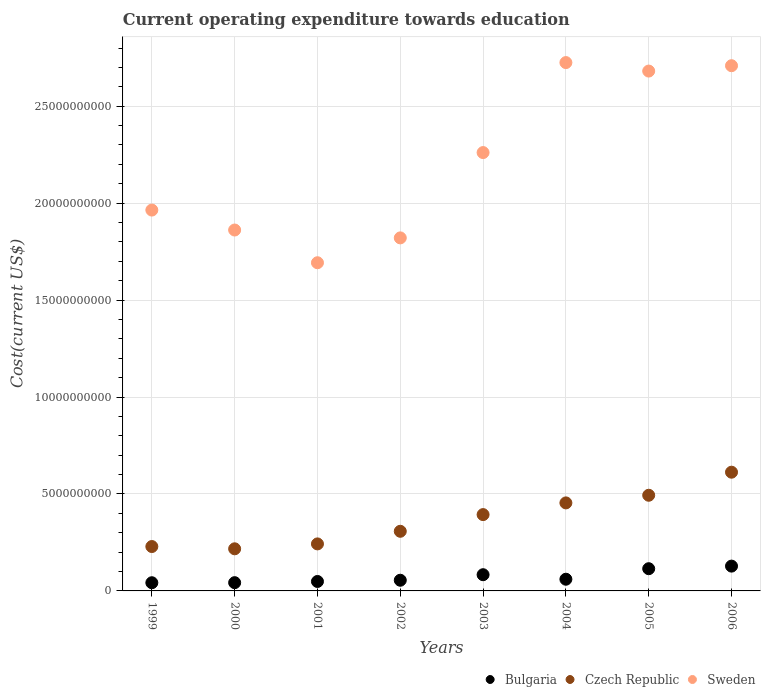How many different coloured dotlines are there?
Offer a very short reply. 3. What is the expenditure towards education in Bulgaria in 2006?
Your answer should be compact. 1.28e+09. Across all years, what is the maximum expenditure towards education in Sweden?
Provide a short and direct response. 2.73e+1. Across all years, what is the minimum expenditure towards education in Sweden?
Keep it short and to the point. 1.69e+1. In which year was the expenditure towards education in Czech Republic maximum?
Offer a terse response. 2006. What is the total expenditure towards education in Czech Republic in the graph?
Provide a succinct answer. 2.95e+1. What is the difference between the expenditure towards education in Czech Republic in 2000 and that in 2005?
Offer a terse response. -2.76e+09. What is the difference between the expenditure towards education in Czech Republic in 2006 and the expenditure towards education in Bulgaria in 1999?
Offer a very short reply. 5.70e+09. What is the average expenditure towards education in Sweden per year?
Keep it short and to the point. 2.21e+1. In the year 2004, what is the difference between the expenditure towards education in Bulgaria and expenditure towards education in Czech Republic?
Make the answer very short. -3.94e+09. What is the ratio of the expenditure towards education in Czech Republic in 2000 to that in 2006?
Your response must be concise. 0.35. Is the expenditure towards education in Bulgaria in 2001 less than that in 2006?
Offer a very short reply. Yes. Is the difference between the expenditure towards education in Bulgaria in 2001 and 2002 greater than the difference between the expenditure towards education in Czech Republic in 2001 and 2002?
Make the answer very short. Yes. What is the difference between the highest and the second highest expenditure towards education in Bulgaria?
Ensure brevity in your answer.  1.33e+08. What is the difference between the highest and the lowest expenditure towards education in Sweden?
Give a very brief answer. 1.03e+1. In how many years, is the expenditure towards education in Bulgaria greater than the average expenditure towards education in Bulgaria taken over all years?
Provide a short and direct response. 3. Is it the case that in every year, the sum of the expenditure towards education in Bulgaria and expenditure towards education in Sweden  is greater than the expenditure towards education in Czech Republic?
Ensure brevity in your answer.  Yes. Does the expenditure towards education in Czech Republic monotonically increase over the years?
Ensure brevity in your answer.  No. Is the expenditure towards education in Czech Republic strictly less than the expenditure towards education in Bulgaria over the years?
Give a very brief answer. No. How many dotlines are there?
Provide a short and direct response. 3. How many years are there in the graph?
Provide a short and direct response. 8. What is the difference between two consecutive major ticks on the Y-axis?
Offer a very short reply. 5.00e+09. Are the values on the major ticks of Y-axis written in scientific E-notation?
Give a very brief answer. No. Where does the legend appear in the graph?
Your answer should be very brief. Bottom right. How are the legend labels stacked?
Keep it short and to the point. Horizontal. What is the title of the graph?
Provide a succinct answer. Current operating expenditure towards education. What is the label or title of the X-axis?
Your response must be concise. Years. What is the label or title of the Y-axis?
Your answer should be very brief. Cost(current US$). What is the Cost(current US$) of Bulgaria in 1999?
Offer a very short reply. 4.22e+08. What is the Cost(current US$) in Czech Republic in 1999?
Offer a terse response. 2.29e+09. What is the Cost(current US$) in Sweden in 1999?
Offer a terse response. 1.96e+1. What is the Cost(current US$) in Bulgaria in 2000?
Provide a short and direct response. 4.26e+08. What is the Cost(current US$) of Czech Republic in 2000?
Ensure brevity in your answer.  2.17e+09. What is the Cost(current US$) of Sweden in 2000?
Make the answer very short. 1.86e+1. What is the Cost(current US$) of Bulgaria in 2001?
Give a very brief answer. 4.87e+08. What is the Cost(current US$) in Czech Republic in 2001?
Your response must be concise. 2.42e+09. What is the Cost(current US$) of Sweden in 2001?
Your answer should be compact. 1.69e+1. What is the Cost(current US$) in Bulgaria in 2002?
Your answer should be compact. 5.51e+08. What is the Cost(current US$) in Czech Republic in 2002?
Your response must be concise. 3.08e+09. What is the Cost(current US$) of Sweden in 2002?
Provide a short and direct response. 1.82e+1. What is the Cost(current US$) of Bulgaria in 2003?
Your answer should be compact. 8.36e+08. What is the Cost(current US$) of Czech Republic in 2003?
Your response must be concise. 3.94e+09. What is the Cost(current US$) of Sweden in 2003?
Your response must be concise. 2.26e+1. What is the Cost(current US$) of Bulgaria in 2004?
Offer a terse response. 6.03e+08. What is the Cost(current US$) of Czech Republic in 2004?
Offer a terse response. 4.54e+09. What is the Cost(current US$) of Sweden in 2004?
Offer a very short reply. 2.73e+1. What is the Cost(current US$) in Bulgaria in 2005?
Offer a very short reply. 1.15e+09. What is the Cost(current US$) in Czech Republic in 2005?
Offer a terse response. 4.93e+09. What is the Cost(current US$) of Sweden in 2005?
Your answer should be very brief. 2.68e+1. What is the Cost(current US$) in Bulgaria in 2006?
Your answer should be very brief. 1.28e+09. What is the Cost(current US$) in Czech Republic in 2006?
Your answer should be very brief. 6.12e+09. What is the Cost(current US$) in Sweden in 2006?
Give a very brief answer. 2.71e+1. Across all years, what is the maximum Cost(current US$) in Bulgaria?
Your answer should be compact. 1.28e+09. Across all years, what is the maximum Cost(current US$) of Czech Republic?
Make the answer very short. 6.12e+09. Across all years, what is the maximum Cost(current US$) in Sweden?
Keep it short and to the point. 2.73e+1. Across all years, what is the minimum Cost(current US$) of Bulgaria?
Offer a very short reply. 4.22e+08. Across all years, what is the minimum Cost(current US$) in Czech Republic?
Give a very brief answer. 2.17e+09. Across all years, what is the minimum Cost(current US$) in Sweden?
Your response must be concise. 1.69e+1. What is the total Cost(current US$) in Bulgaria in the graph?
Ensure brevity in your answer.  5.75e+09. What is the total Cost(current US$) of Czech Republic in the graph?
Offer a very short reply. 2.95e+1. What is the total Cost(current US$) in Sweden in the graph?
Your response must be concise. 1.77e+11. What is the difference between the Cost(current US$) in Bulgaria in 1999 and that in 2000?
Your response must be concise. -3.43e+06. What is the difference between the Cost(current US$) in Czech Republic in 1999 and that in 2000?
Your response must be concise. 1.17e+08. What is the difference between the Cost(current US$) of Sweden in 1999 and that in 2000?
Provide a short and direct response. 1.03e+09. What is the difference between the Cost(current US$) of Bulgaria in 1999 and that in 2001?
Your answer should be very brief. -6.50e+07. What is the difference between the Cost(current US$) in Czech Republic in 1999 and that in 2001?
Give a very brief answer. -1.36e+08. What is the difference between the Cost(current US$) in Sweden in 1999 and that in 2001?
Your response must be concise. 2.72e+09. What is the difference between the Cost(current US$) of Bulgaria in 1999 and that in 2002?
Give a very brief answer. -1.28e+08. What is the difference between the Cost(current US$) of Czech Republic in 1999 and that in 2002?
Your response must be concise. -7.86e+08. What is the difference between the Cost(current US$) of Sweden in 1999 and that in 2002?
Your answer should be very brief. 1.43e+09. What is the difference between the Cost(current US$) of Bulgaria in 1999 and that in 2003?
Provide a short and direct response. -4.14e+08. What is the difference between the Cost(current US$) of Czech Republic in 1999 and that in 2003?
Provide a succinct answer. -1.65e+09. What is the difference between the Cost(current US$) of Sweden in 1999 and that in 2003?
Your answer should be compact. -2.97e+09. What is the difference between the Cost(current US$) in Bulgaria in 1999 and that in 2004?
Provide a short and direct response. -1.81e+08. What is the difference between the Cost(current US$) of Czech Republic in 1999 and that in 2004?
Your response must be concise. -2.25e+09. What is the difference between the Cost(current US$) in Sweden in 1999 and that in 2004?
Keep it short and to the point. -7.61e+09. What is the difference between the Cost(current US$) in Bulgaria in 1999 and that in 2005?
Make the answer very short. -7.24e+08. What is the difference between the Cost(current US$) of Czech Republic in 1999 and that in 2005?
Give a very brief answer. -2.64e+09. What is the difference between the Cost(current US$) of Sweden in 1999 and that in 2005?
Ensure brevity in your answer.  -7.17e+09. What is the difference between the Cost(current US$) of Bulgaria in 1999 and that in 2006?
Your answer should be very brief. -8.57e+08. What is the difference between the Cost(current US$) of Czech Republic in 1999 and that in 2006?
Provide a succinct answer. -3.83e+09. What is the difference between the Cost(current US$) of Sweden in 1999 and that in 2006?
Keep it short and to the point. -7.45e+09. What is the difference between the Cost(current US$) in Bulgaria in 2000 and that in 2001?
Give a very brief answer. -6.15e+07. What is the difference between the Cost(current US$) of Czech Republic in 2000 and that in 2001?
Make the answer very short. -2.52e+08. What is the difference between the Cost(current US$) in Sweden in 2000 and that in 2001?
Give a very brief answer. 1.69e+09. What is the difference between the Cost(current US$) in Bulgaria in 2000 and that in 2002?
Give a very brief answer. -1.25e+08. What is the difference between the Cost(current US$) of Czech Republic in 2000 and that in 2002?
Provide a succinct answer. -9.03e+08. What is the difference between the Cost(current US$) of Sweden in 2000 and that in 2002?
Offer a very short reply. 4.06e+08. What is the difference between the Cost(current US$) of Bulgaria in 2000 and that in 2003?
Provide a succinct answer. -4.11e+08. What is the difference between the Cost(current US$) in Czech Republic in 2000 and that in 2003?
Provide a short and direct response. -1.76e+09. What is the difference between the Cost(current US$) in Sweden in 2000 and that in 2003?
Offer a very short reply. -3.99e+09. What is the difference between the Cost(current US$) in Bulgaria in 2000 and that in 2004?
Make the answer very short. -1.78e+08. What is the difference between the Cost(current US$) in Czech Republic in 2000 and that in 2004?
Your response must be concise. -2.37e+09. What is the difference between the Cost(current US$) of Sweden in 2000 and that in 2004?
Offer a very short reply. -8.64e+09. What is the difference between the Cost(current US$) in Bulgaria in 2000 and that in 2005?
Offer a very short reply. -7.20e+08. What is the difference between the Cost(current US$) of Czech Republic in 2000 and that in 2005?
Give a very brief answer. -2.76e+09. What is the difference between the Cost(current US$) in Sweden in 2000 and that in 2005?
Provide a succinct answer. -8.20e+09. What is the difference between the Cost(current US$) of Bulgaria in 2000 and that in 2006?
Your response must be concise. -8.53e+08. What is the difference between the Cost(current US$) of Czech Republic in 2000 and that in 2006?
Ensure brevity in your answer.  -3.95e+09. What is the difference between the Cost(current US$) in Sweden in 2000 and that in 2006?
Ensure brevity in your answer.  -8.47e+09. What is the difference between the Cost(current US$) in Bulgaria in 2001 and that in 2002?
Your answer should be compact. -6.35e+07. What is the difference between the Cost(current US$) in Czech Republic in 2001 and that in 2002?
Provide a short and direct response. -6.51e+08. What is the difference between the Cost(current US$) in Sweden in 2001 and that in 2002?
Provide a short and direct response. -1.28e+09. What is the difference between the Cost(current US$) in Bulgaria in 2001 and that in 2003?
Ensure brevity in your answer.  -3.49e+08. What is the difference between the Cost(current US$) of Czech Republic in 2001 and that in 2003?
Offer a terse response. -1.51e+09. What is the difference between the Cost(current US$) in Sweden in 2001 and that in 2003?
Provide a short and direct response. -5.68e+09. What is the difference between the Cost(current US$) in Bulgaria in 2001 and that in 2004?
Provide a succinct answer. -1.16e+08. What is the difference between the Cost(current US$) in Czech Republic in 2001 and that in 2004?
Your response must be concise. -2.11e+09. What is the difference between the Cost(current US$) of Sweden in 2001 and that in 2004?
Your answer should be compact. -1.03e+1. What is the difference between the Cost(current US$) of Bulgaria in 2001 and that in 2005?
Provide a succinct answer. -6.59e+08. What is the difference between the Cost(current US$) in Czech Republic in 2001 and that in 2005?
Your answer should be compact. -2.51e+09. What is the difference between the Cost(current US$) of Sweden in 2001 and that in 2005?
Your answer should be compact. -9.89e+09. What is the difference between the Cost(current US$) in Bulgaria in 2001 and that in 2006?
Provide a succinct answer. -7.92e+08. What is the difference between the Cost(current US$) in Czech Republic in 2001 and that in 2006?
Make the answer very short. -3.70e+09. What is the difference between the Cost(current US$) of Sweden in 2001 and that in 2006?
Offer a terse response. -1.02e+1. What is the difference between the Cost(current US$) of Bulgaria in 2002 and that in 2003?
Your answer should be compact. -2.86e+08. What is the difference between the Cost(current US$) in Czech Republic in 2002 and that in 2003?
Your answer should be very brief. -8.61e+08. What is the difference between the Cost(current US$) in Sweden in 2002 and that in 2003?
Offer a terse response. -4.40e+09. What is the difference between the Cost(current US$) in Bulgaria in 2002 and that in 2004?
Ensure brevity in your answer.  -5.25e+07. What is the difference between the Cost(current US$) of Czech Republic in 2002 and that in 2004?
Give a very brief answer. -1.46e+09. What is the difference between the Cost(current US$) of Sweden in 2002 and that in 2004?
Provide a short and direct response. -9.04e+09. What is the difference between the Cost(current US$) in Bulgaria in 2002 and that in 2005?
Your answer should be compact. -5.95e+08. What is the difference between the Cost(current US$) in Czech Republic in 2002 and that in 2005?
Your answer should be very brief. -1.86e+09. What is the difference between the Cost(current US$) in Sweden in 2002 and that in 2005?
Ensure brevity in your answer.  -8.60e+09. What is the difference between the Cost(current US$) of Bulgaria in 2002 and that in 2006?
Ensure brevity in your answer.  -7.28e+08. What is the difference between the Cost(current US$) of Czech Republic in 2002 and that in 2006?
Offer a terse response. -3.05e+09. What is the difference between the Cost(current US$) in Sweden in 2002 and that in 2006?
Ensure brevity in your answer.  -8.88e+09. What is the difference between the Cost(current US$) of Bulgaria in 2003 and that in 2004?
Ensure brevity in your answer.  2.33e+08. What is the difference between the Cost(current US$) in Czech Republic in 2003 and that in 2004?
Offer a terse response. -6.04e+08. What is the difference between the Cost(current US$) in Sweden in 2003 and that in 2004?
Your response must be concise. -4.64e+09. What is the difference between the Cost(current US$) of Bulgaria in 2003 and that in 2005?
Provide a short and direct response. -3.10e+08. What is the difference between the Cost(current US$) in Czech Republic in 2003 and that in 2005?
Make the answer very short. -9.98e+08. What is the difference between the Cost(current US$) in Sweden in 2003 and that in 2005?
Make the answer very short. -4.20e+09. What is the difference between the Cost(current US$) in Bulgaria in 2003 and that in 2006?
Your answer should be very brief. -4.43e+08. What is the difference between the Cost(current US$) of Czech Republic in 2003 and that in 2006?
Your answer should be very brief. -2.19e+09. What is the difference between the Cost(current US$) in Sweden in 2003 and that in 2006?
Give a very brief answer. -4.48e+09. What is the difference between the Cost(current US$) in Bulgaria in 2004 and that in 2005?
Provide a succinct answer. -5.43e+08. What is the difference between the Cost(current US$) in Czech Republic in 2004 and that in 2005?
Offer a terse response. -3.94e+08. What is the difference between the Cost(current US$) in Sweden in 2004 and that in 2005?
Make the answer very short. 4.38e+08. What is the difference between the Cost(current US$) in Bulgaria in 2004 and that in 2006?
Your answer should be very brief. -6.76e+08. What is the difference between the Cost(current US$) in Czech Republic in 2004 and that in 2006?
Offer a terse response. -1.58e+09. What is the difference between the Cost(current US$) of Sweden in 2004 and that in 2006?
Give a very brief answer. 1.61e+08. What is the difference between the Cost(current US$) of Bulgaria in 2005 and that in 2006?
Your answer should be compact. -1.33e+08. What is the difference between the Cost(current US$) in Czech Republic in 2005 and that in 2006?
Provide a succinct answer. -1.19e+09. What is the difference between the Cost(current US$) of Sweden in 2005 and that in 2006?
Make the answer very short. -2.76e+08. What is the difference between the Cost(current US$) in Bulgaria in 1999 and the Cost(current US$) in Czech Republic in 2000?
Your response must be concise. -1.75e+09. What is the difference between the Cost(current US$) in Bulgaria in 1999 and the Cost(current US$) in Sweden in 2000?
Offer a very short reply. -1.82e+1. What is the difference between the Cost(current US$) of Czech Republic in 1999 and the Cost(current US$) of Sweden in 2000?
Offer a terse response. -1.63e+1. What is the difference between the Cost(current US$) of Bulgaria in 1999 and the Cost(current US$) of Czech Republic in 2001?
Make the answer very short. -2.00e+09. What is the difference between the Cost(current US$) of Bulgaria in 1999 and the Cost(current US$) of Sweden in 2001?
Ensure brevity in your answer.  -1.65e+1. What is the difference between the Cost(current US$) in Czech Republic in 1999 and the Cost(current US$) in Sweden in 2001?
Your response must be concise. -1.46e+1. What is the difference between the Cost(current US$) of Bulgaria in 1999 and the Cost(current US$) of Czech Republic in 2002?
Your response must be concise. -2.65e+09. What is the difference between the Cost(current US$) in Bulgaria in 1999 and the Cost(current US$) in Sweden in 2002?
Keep it short and to the point. -1.78e+1. What is the difference between the Cost(current US$) in Czech Republic in 1999 and the Cost(current US$) in Sweden in 2002?
Ensure brevity in your answer.  -1.59e+1. What is the difference between the Cost(current US$) of Bulgaria in 1999 and the Cost(current US$) of Czech Republic in 2003?
Provide a short and direct response. -3.51e+09. What is the difference between the Cost(current US$) in Bulgaria in 1999 and the Cost(current US$) in Sweden in 2003?
Make the answer very short. -2.22e+1. What is the difference between the Cost(current US$) in Czech Republic in 1999 and the Cost(current US$) in Sweden in 2003?
Offer a very short reply. -2.03e+1. What is the difference between the Cost(current US$) in Bulgaria in 1999 and the Cost(current US$) in Czech Republic in 2004?
Your answer should be compact. -4.12e+09. What is the difference between the Cost(current US$) of Bulgaria in 1999 and the Cost(current US$) of Sweden in 2004?
Your answer should be compact. -2.68e+1. What is the difference between the Cost(current US$) of Czech Republic in 1999 and the Cost(current US$) of Sweden in 2004?
Provide a short and direct response. -2.50e+1. What is the difference between the Cost(current US$) of Bulgaria in 1999 and the Cost(current US$) of Czech Republic in 2005?
Provide a succinct answer. -4.51e+09. What is the difference between the Cost(current US$) of Bulgaria in 1999 and the Cost(current US$) of Sweden in 2005?
Provide a short and direct response. -2.64e+1. What is the difference between the Cost(current US$) in Czech Republic in 1999 and the Cost(current US$) in Sweden in 2005?
Offer a very short reply. -2.45e+1. What is the difference between the Cost(current US$) in Bulgaria in 1999 and the Cost(current US$) in Czech Republic in 2006?
Ensure brevity in your answer.  -5.70e+09. What is the difference between the Cost(current US$) in Bulgaria in 1999 and the Cost(current US$) in Sweden in 2006?
Your response must be concise. -2.67e+1. What is the difference between the Cost(current US$) of Czech Republic in 1999 and the Cost(current US$) of Sweden in 2006?
Your answer should be very brief. -2.48e+1. What is the difference between the Cost(current US$) of Bulgaria in 2000 and the Cost(current US$) of Czech Republic in 2001?
Keep it short and to the point. -2.00e+09. What is the difference between the Cost(current US$) of Bulgaria in 2000 and the Cost(current US$) of Sweden in 2001?
Your response must be concise. -1.65e+1. What is the difference between the Cost(current US$) in Czech Republic in 2000 and the Cost(current US$) in Sweden in 2001?
Your answer should be compact. -1.48e+1. What is the difference between the Cost(current US$) of Bulgaria in 2000 and the Cost(current US$) of Czech Republic in 2002?
Your response must be concise. -2.65e+09. What is the difference between the Cost(current US$) of Bulgaria in 2000 and the Cost(current US$) of Sweden in 2002?
Your answer should be compact. -1.78e+1. What is the difference between the Cost(current US$) in Czech Republic in 2000 and the Cost(current US$) in Sweden in 2002?
Give a very brief answer. -1.60e+1. What is the difference between the Cost(current US$) of Bulgaria in 2000 and the Cost(current US$) of Czech Republic in 2003?
Give a very brief answer. -3.51e+09. What is the difference between the Cost(current US$) in Bulgaria in 2000 and the Cost(current US$) in Sweden in 2003?
Provide a short and direct response. -2.22e+1. What is the difference between the Cost(current US$) in Czech Republic in 2000 and the Cost(current US$) in Sweden in 2003?
Provide a short and direct response. -2.04e+1. What is the difference between the Cost(current US$) in Bulgaria in 2000 and the Cost(current US$) in Czech Republic in 2004?
Offer a terse response. -4.11e+09. What is the difference between the Cost(current US$) of Bulgaria in 2000 and the Cost(current US$) of Sweden in 2004?
Your answer should be compact. -2.68e+1. What is the difference between the Cost(current US$) of Czech Republic in 2000 and the Cost(current US$) of Sweden in 2004?
Provide a succinct answer. -2.51e+1. What is the difference between the Cost(current US$) of Bulgaria in 2000 and the Cost(current US$) of Czech Republic in 2005?
Give a very brief answer. -4.51e+09. What is the difference between the Cost(current US$) of Bulgaria in 2000 and the Cost(current US$) of Sweden in 2005?
Your response must be concise. -2.64e+1. What is the difference between the Cost(current US$) of Czech Republic in 2000 and the Cost(current US$) of Sweden in 2005?
Your answer should be compact. -2.46e+1. What is the difference between the Cost(current US$) in Bulgaria in 2000 and the Cost(current US$) in Czech Republic in 2006?
Your response must be concise. -5.70e+09. What is the difference between the Cost(current US$) of Bulgaria in 2000 and the Cost(current US$) of Sweden in 2006?
Your answer should be very brief. -2.67e+1. What is the difference between the Cost(current US$) of Czech Republic in 2000 and the Cost(current US$) of Sweden in 2006?
Your response must be concise. -2.49e+1. What is the difference between the Cost(current US$) of Bulgaria in 2001 and the Cost(current US$) of Czech Republic in 2002?
Keep it short and to the point. -2.59e+09. What is the difference between the Cost(current US$) of Bulgaria in 2001 and the Cost(current US$) of Sweden in 2002?
Provide a short and direct response. -1.77e+1. What is the difference between the Cost(current US$) of Czech Republic in 2001 and the Cost(current US$) of Sweden in 2002?
Offer a terse response. -1.58e+1. What is the difference between the Cost(current US$) in Bulgaria in 2001 and the Cost(current US$) in Czech Republic in 2003?
Offer a terse response. -3.45e+09. What is the difference between the Cost(current US$) of Bulgaria in 2001 and the Cost(current US$) of Sweden in 2003?
Keep it short and to the point. -2.21e+1. What is the difference between the Cost(current US$) in Czech Republic in 2001 and the Cost(current US$) in Sweden in 2003?
Your answer should be very brief. -2.02e+1. What is the difference between the Cost(current US$) of Bulgaria in 2001 and the Cost(current US$) of Czech Republic in 2004?
Give a very brief answer. -4.05e+09. What is the difference between the Cost(current US$) in Bulgaria in 2001 and the Cost(current US$) in Sweden in 2004?
Provide a short and direct response. -2.68e+1. What is the difference between the Cost(current US$) in Czech Republic in 2001 and the Cost(current US$) in Sweden in 2004?
Your response must be concise. -2.48e+1. What is the difference between the Cost(current US$) of Bulgaria in 2001 and the Cost(current US$) of Czech Republic in 2005?
Offer a terse response. -4.45e+09. What is the difference between the Cost(current US$) in Bulgaria in 2001 and the Cost(current US$) in Sweden in 2005?
Provide a short and direct response. -2.63e+1. What is the difference between the Cost(current US$) in Czech Republic in 2001 and the Cost(current US$) in Sweden in 2005?
Provide a short and direct response. -2.44e+1. What is the difference between the Cost(current US$) of Bulgaria in 2001 and the Cost(current US$) of Czech Republic in 2006?
Make the answer very short. -5.64e+09. What is the difference between the Cost(current US$) of Bulgaria in 2001 and the Cost(current US$) of Sweden in 2006?
Offer a terse response. -2.66e+1. What is the difference between the Cost(current US$) in Czech Republic in 2001 and the Cost(current US$) in Sweden in 2006?
Keep it short and to the point. -2.47e+1. What is the difference between the Cost(current US$) of Bulgaria in 2002 and the Cost(current US$) of Czech Republic in 2003?
Offer a very short reply. -3.39e+09. What is the difference between the Cost(current US$) of Bulgaria in 2002 and the Cost(current US$) of Sweden in 2003?
Make the answer very short. -2.21e+1. What is the difference between the Cost(current US$) in Czech Republic in 2002 and the Cost(current US$) in Sweden in 2003?
Make the answer very short. -1.95e+1. What is the difference between the Cost(current US$) of Bulgaria in 2002 and the Cost(current US$) of Czech Republic in 2004?
Your response must be concise. -3.99e+09. What is the difference between the Cost(current US$) of Bulgaria in 2002 and the Cost(current US$) of Sweden in 2004?
Offer a terse response. -2.67e+1. What is the difference between the Cost(current US$) of Czech Republic in 2002 and the Cost(current US$) of Sweden in 2004?
Give a very brief answer. -2.42e+1. What is the difference between the Cost(current US$) of Bulgaria in 2002 and the Cost(current US$) of Czech Republic in 2005?
Keep it short and to the point. -4.38e+09. What is the difference between the Cost(current US$) in Bulgaria in 2002 and the Cost(current US$) in Sweden in 2005?
Offer a very short reply. -2.63e+1. What is the difference between the Cost(current US$) of Czech Republic in 2002 and the Cost(current US$) of Sweden in 2005?
Provide a succinct answer. -2.37e+1. What is the difference between the Cost(current US$) of Bulgaria in 2002 and the Cost(current US$) of Czech Republic in 2006?
Your answer should be very brief. -5.57e+09. What is the difference between the Cost(current US$) of Bulgaria in 2002 and the Cost(current US$) of Sweden in 2006?
Your answer should be compact. -2.65e+1. What is the difference between the Cost(current US$) in Czech Republic in 2002 and the Cost(current US$) in Sweden in 2006?
Your answer should be compact. -2.40e+1. What is the difference between the Cost(current US$) of Bulgaria in 2003 and the Cost(current US$) of Czech Republic in 2004?
Keep it short and to the point. -3.70e+09. What is the difference between the Cost(current US$) of Bulgaria in 2003 and the Cost(current US$) of Sweden in 2004?
Offer a terse response. -2.64e+1. What is the difference between the Cost(current US$) of Czech Republic in 2003 and the Cost(current US$) of Sweden in 2004?
Your answer should be compact. -2.33e+1. What is the difference between the Cost(current US$) in Bulgaria in 2003 and the Cost(current US$) in Czech Republic in 2005?
Provide a succinct answer. -4.10e+09. What is the difference between the Cost(current US$) of Bulgaria in 2003 and the Cost(current US$) of Sweden in 2005?
Provide a short and direct response. -2.60e+1. What is the difference between the Cost(current US$) of Czech Republic in 2003 and the Cost(current US$) of Sweden in 2005?
Make the answer very short. -2.29e+1. What is the difference between the Cost(current US$) in Bulgaria in 2003 and the Cost(current US$) in Czech Republic in 2006?
Offer a terse response. -5.29e+09. What is the difference between the Cost(current US$) of Bulgaria in 2003 and the Cost(current US$) of Sweden in 2006?
Your response must be concise. -2.63e+1. What is the difference between the Cost(current US$) of Czech Republic in 2003 and the Cost(current US$) of Sweden in 2006?
Make the answer very short. -2.32e+1. What is the difference between the Cost(current US$) of Bulgaria in 2004 and the Cost(current US$) of Czech Republic in 2005?
Your response must be concise. -4.33e+09. What is the difference between the Cost(current US$) of Bulgaria in 2004 and the Cost(current US$) of Sweden in 2005?
Provide a succinct answer. -2.62e+1. What is the difference between the Cost(current US$) of Czech Republic in 2004 and the Cost(current US$) of Sweden in 2005?
Your answer should be very brief. -2.23e+1. What is the difference between the Cost(current US$) in Bulgaria in 2004 and the Cost(current US$) in Czech Republic in 2006?
Offer a very short reply. -5.52e+09. What is the difference between the Cost(current US$) in Bulgaria in 2004 and the Cost(current US$) in Sweden in 2006?
Provide a short and direct response. -2.65e+1. What is the difference between the Cost(current US$) of Czech Republic in 2004 and the Cost(current US$) of Sweden in 2006?
Provide a short and direct response. -2.25e+1. What is the difference between the Cost(current US$) in Bulgaria in 2005 and the Cost(current US$) in Czech Republic in 2006?
Make the answer very short. -4.98e+09. What is the difference between the Cost(current US$) in Bulgaria in 2005 and the Cost(current US$) in Sweden in 2006?
Give a very brief answer. -2.59e+1. What is the difference between the Cost(current US$) in Czech Republic in 2005 and the Cost(current US$) in Sweden in 2006?
Your response must be concise. -2.22e+1. What is the average Cost(current US$) in Bulgaria per year?
Make the answer very short. 7.19e+08. What is the average Cost(current US$) of Czech Republic per year?
Keep it short and to the point. 3.69e+09. What is the average Cost(current US$) in Sweden per year?
Make the answer very short. 2.21e+1. In the year 1999, what is the difference between the Cost(current US$) in Bulgaria and Cost(current US$) in Czech Republic?
Keep it short and to the point. -1.87e+09. In the year 1999, what is the difference between the Cost(current US$) in Bulgaria and Cost(current US$) in Sweden?
Your answer should be compact. -1.92e+1. In the year 1999, what is the difference between the Cost(current US$) in Czech Republic and Cost(current US$) in Sweden?
Make the answer very short. -1.74e+1. In the year 2000, what is the difference between the Cost(current US$) of Bulgaria and Cost(current US$) of Czech Republic?
Offer a terse response. -1.75e+09. In the year 2000, what is the difference between the Cost(current US$) in Bulgaria and Cost(current US$) in Sweden?
Your response must be concise. -1.82e+1. In the year 2000, what is the difference between the Cost(current US$) in Czech Republic and Cost(current US$) in Sweden?
Provide a short and direct response. -1.64e+1. In the year 2001, what is the difference between the Cost(current US$) in Bulgaria and Cost(current US$) in Czech Republic?
Offer a terse response. -1.94e+09. In the year 2001, what is the difference between the Cost(current US$) in Bulgaria and Cost(current US$) in Sweden?
Provide a succinct answer. -1.64e+1. In the year 2001, what is the difference between the Cost(current US$) in Czech Republic and Cost(current US$) in Sweden?
Keep it short and to the point. -1.45e+1. In the year 2002, what is the difference between the Cost(current US$) in Bulgaria and Cost(current US$) in Czech Republic?
Provide a short and direct response. -2.52e+09. In the year 2002, what is the difference between the Cost(current US$) in Bulgaria and Cost(current US$) in Sweden?
Your answer should be very brief. -1.77e+1. In the year 2002, what is the difference between the Cost(current US$) of Czech Republic and Cost(current US$) of Sweden?
Make the answer very short. -1.51e+1. In the year 2003, what is the difference between the Cost(current US$) in Bulgaria and Cost(current US$) in Czech Republic?
Give a very brief answer. -3.10e+09. In the year 2003, what is the difference between the Cost(current US$) of Bulgaria and Cost(current US$) of Sweden?
Offer a terse response. -2.18e+1. In the year 2003, what is the difference between the Cost(current US$) in Czech Republic and Cost(current US$) in Sweden?
Provide a succinct answer. -1.87e+1. In the year 2004, what is the difference between the Cost(current US$) in Bulgaria and Cost(current US$) in Czech Republic?
Provide a short and direct response. -3.94e+09. In the year 2004, what is the difference between the Cost(current US$) in Bulgaria and Cost(current US$) in Sweden?
Give a very brief answer. -2.66e+1. In the year 2004, what is the difference between the Cost(current US$) of Czech Republic and Cost(current US$) of Sweden?
Make the answer very short. -2.27e+1. In the year 2005, what is the difference between the Cost(current US$) of Bulgaria and Cost(current US$) of Czech Republic?
Offer a very short reply. -3.79e+09. In the year 2005, what is the difference between the Cost(current US$) of Bulgaria and Cost(current US$) of Sweden?
Provide a short and direct response. -2.57e+1. In the year 2005, what is the difference between the Cost(current US$) of Czech Republic and Cost(current US$) of Sweden?
Give a very brief answer. -2.19e+1. In the year 2006, what is the difference between the Cost(current US$) of Bulgaria and Cost(current US$) of Czech Republic?
Keep it short and to the point. -4.84e+09. In the year 2006, what is the difference between the Cost(current US$) in Bulgaria and Cost(current US$) in Sweden?
Provide a succinct answer. -2.58e+1. In the year 2006, what is the difference between the Cost(current US$) in Czech Republic and Cost(current US$) in Sweden?
Offer a terse response. -2.10e+1. What is the ratio of the Cost(current US$) in Bulgaria in 1999 to that in 2000?
Your answer should be very brief. 0.99. What is the ratio of the Cost(current US$) of Czech Republic in 1999 to that in 2000?
Give a very brief answer. 1.05. What is the ratio of the Cost(current US$) of Sweden in 1999 to that in 2000?
Keep it short and to the point. 1.06. What is the ratio of the Cost(current US$) in Bulgaria in 1999 to that in 2001?
Make the answer very short. 0.87. What is the ratio of the Cost(current US$) of Czech Republic in 1999 to that in 2001?
Your answer should be compact. 0.94. What is the ratio of the Cost(current US$) of Sweden in 1999 to that in 2001?
Your response must be concise. 1.16. What is the ratio of the Cost(current US$) in Bulgaria in 1999 to that in 2002?
Your answer should be compact. 0.77. What is the ratio of the Cost(current US$) of Czech Republic in 1999 to that in 2002?
Ensure brevity in your answer.  0.74. What is the ratio of the Cost(current US$) in Sweden in 1999 to that in 2002?
Give a very brief answer. 1.08. What is the ratio of the Cost(current US$) in Bulgaria in 1999 to that in 2003?
Offer a very short reply. 0.5. What is the ratio of the Cost(current US$) in Czech Republic in 1999 to that in 2003?
Your answer should be very brief. 0.58. What is the ratio of the Cost(current US$) of Sweden in 1999 to that in 2003?
Make the answer very short. 0.87. What is the ratio of the Cost(current US$) of Czech Republic in 1999 to that in 2004?
Your answer should be compact. 0.5. What is the ratio of the Cost(current US$) of Sweden in 1999 to that in 2004?
Offer a terse response. 0.72. What is the ratio of the Cost(current US$) of Bulgaria in 1999 to that in 2005?
Keep it short and to the point. 0.37. What is the ratio of the Cost(current US$) of Czech Republic in 1999 to that in 2005?
Keep it short and to the point. 0.46. What is the ratio of the Cost(current US$) in Sweden in 1999 to that in 2005?
Your answer should be compact. 0.73. What is the ratio of the Cost(current US$) of Bulgaria in 1999 to that in 2006?
Provide a succinct answer. 0.33. What is the ratio of the Cost(current US$) in Czech Republic in 1999 to that in 2006?
Provide a short and direct response. 0.37. What is the ratio of the Cost(current US$) in Sweden in 1999 to that in 2006?
Ensure brevity in your answer.  0.73. What is the ratio of the Cost(current US$) of Bulgaria in 2000 to that in 2001?
Ensure brevity in your answer.  0.87. What is the ratio of the Cost(current US$) of Czech Republic in 2000 to that in 2001?
Provide a succinct answer. 0.9. What is the ratio of the Cost(current US$) of Sweden in 2000 to that in 2001?
Offer a terse response. 1.1. What is the ratio of the Cost(current US$) in Bulgaria in 2000 to that in 2002?
Your answer should be compact. 0.77. What is the ratio of the Cost(current US$) in Czech Republic in 2000 to that in 2002?
Keep it short and to the point. 0.71. What is the ratio of the Cost(current US$) of Sweden in 2000 to that in 2002?
Make the answer very short. 1.02. What is the ratio of the Cost(current US$) in Bulgaria in 2000 to that in 2003?
Your response must be concise. 0.51. What is the ratio of the Cost(current US$) in Czech Republic in 2000 to that in 2003?
Ensure brevity in your answer.  0.55. What is the ratio of the Cost(current US$) in Sweden in 2000 to that in 2003?
Your answer should be very brief. 0.82. What is the ratio of the Cost(current US$) of Bulgaria in 2000 to that in 2004?
Keep it short and to the point. 0.71. What is the ratio of the Cost(current US$) in Czech Republic in 2000 to that in 2004?
Your answer should be very brief. 0.48. What is the ratio of the Cost(current US$) in Sweden in 2000 to that in 2004?
Your answer should be compact. 0.68. What is the ratio of the Cost(current US$) in Bulgaria in 2000 to that in 2005?
Provide a succinct answer. 0.37. What is the ratio of the Cost(current US$) of Czech Republic in 2000 to that in 2005?
Make the answer very short. 0.44. What is the ratio of the Cost(current US$) of Sweden in 2000 to that in 2005?
Keep it short and to the point. 0.69. What is the ratio of the Cost(current US$) of Bulgaria in 2000 to that in 2006?
Keep it short and to the point. 0.33. What is the ratio of the Cost(current US$) in Czech Republic in 2000 to that in 2006?
Keep it short and to the point. 0.35. What is the ratio of the Cost(current US$) in Sweden in 2000 to that in 2006?
Your answer should be very brief. 0.69. What is the ratio of the Cost(current US$) of Bulgaria in 2001 to that in 2002?
Offer a very short reply. 0.88. What is the ratio of the Cost(current US$) in Czech Republic in 2001 to that in 2002?
Your answer should be very brief. 0.79. What is the ratio of the Cost(current US$) in Sweden in 2001 to that in 2002?
Your answer should be very brief. 0.93. What is the ratio of the Cost(current US$) of Bulgaria in 2001 to that in 2003?
Provide a short and direct response. 0.58. What is the ratio of the Cost(current US$) in Czech Republic in 2001 to that in 2003?
Make the answer very short. 0.62. What is the ratio of the Cost(current US$) in Sweden in 2001 to that in 2003?
Your response must be concise. 0.75. What is the ratio of the Cost(current US$) of Bulgaria in 2001 to that in 2004?
Give a very brief answer. 0.81. What is the ratio of the Cost(current US$) in Czech Republic in 2001 to that in 2004?
Ensure brevity in your answer.  0.53. What is the ratio of the Cost(current US$) in Sweden in 2001 to that in 2004?
Provide a succinct answer. 0.62. What is the ratio of the Cost(current US$) in Bulgaria in 2001 to that in 2005?
Offer a very short reply. 0.43. What is the ratio of the Cost(current US$) of Czech Republic in 2001 to that in 2005?
Offer a terse response. 0.49. What is the ratio of the Cost(current US$) of Sweden in 2001 to that in 2005?
Ensure brevity in your answer.  0.63. What is the ratio of the Cost(current US$) in Bulgaria in 2001 to that in 2006?
Keep it short and to the point. 0.38. What is the ratio of the Cost(current US$) in Czech Republic in 2001 to that in 2006?
Give a very brief answer. 0.4. What is the ratio of the Cost(current US$) of Sweden in 2001 to that in 2006?
Ensure brevity in your answer.  0.62. What is the ratio of the Cost(current US$) in Bulgaria in 2002 to that in 2003?
Keep it short and to the point. 0.66. What is the ratio of the Cost(current US$) in Czech Republic in 2002 to that in 2003?
Provide a succinct answer. 0.78. What is the ratio of the Cost(current US$) in Sweden in 2002 to that in 2003?
Make the answer very short. 0.81. What is the ratio of the Cost(current US$) in Bulgaria in 2002 to that in 2004?
Ensure brevity in your answer.  0.91. What is the ratio of the Cost(current US$) of Czech Republic in 2002 to that in 2004?
Provide a succinct answer. 0.68. What is the ratio of the Cost(current US$) in Sweden in 2002 to that in 2004?
Your answer should be compact. 0.67. What is the ratio of the Cost(current US$) in Bulgaria in 2002 to that in 2005?
Your answer should be compact. 0.48. What is the ratio of the Cost(current US$) of Czech Republic in 2002 to that in 2005?
Give a very brief answer. 0.62. What is the ratio of the Cost(current US$) in Sweden in 2002 to that in 2005?
Your response must be concise. 0.68. What is the ratio of the Cost(current US$) of Bulgaria in 2002 to that in 2006?
Offer a very short reply. 0.43. What is the ratio of the Cost(current US$) in Czech Republic in 2002 to that in 2006?
Keep it short and to the point. 0.5. What is the ratio of the Cost(current US$) in Sweden in 2002 to that in 2006?
Offer a terse response. 0.67. What is the ratio of the Cost(current US$) in Bulgaria in 2003 to that in 2004?
Your answer should be very brief. 1.39. What is the ratio of the Cost(current US$) of Czech Republic in 2003 to that in 2004?
Offer a very short reply. 0.87. What is the ratio of the Cost(current US$) of Sweden in 2003 to that in 2004?
Your answer should be compact. 0.83. What is the ratio of the Cost(current US$) of Bulgaria in 2003 to that in 2005?
Give a very brief answer. 0.73. What is the ratio of the Cost(current US$) of Czech Republic in 2003 to that in 2005?
Your answer should be very brief. 0.8. What is the ratio of the Cost(current US$) in Sweden in 2003 to that in 2005?
Give a very brief answer. 0.84. What is the ratio of the Cost(current US$) of Bulgaria in 2003 to that in 2006?
Keep it short and to the point. 0.65. What is the ratio of the Cost(current US$) in Czech Republic in 2003 to that in 2006?
Give a very brief answer. 0.64. What is the ratio of the Cost(current US$) in Sweden in 2003 to that in 2006?
Your answer should be compact. 0.83. What is the ratio of the Cost(current US$) of Bulgaria in 2004 to that in 2005?
Offer a terse response. 0.53. What is the ratio of the Cost(current US$) of Czech Republic in 2004 to that in 2005?
Your answer should be very brief. 0.92. What is the ratio of the Cost(current US$) of Sweden in 2004 to that in 2005?
Ensure brevity in your answer.  1.02. What is the ratio of the Cost(current US$) of Bulgaria in 2004 to that in 2006?
Make the answer very short. 0.47. What is the ratio of the Cost(current US$) of Czech Republic in 2004 to that in 2006?
Keep it short and to the point. 0.74. What is the ratio of the Cost(current US$) in Bulgaria in 2005 to that in 2006?
Your answer should be very brief. 0.9. What is the ratio of the Cost(current US$) in Czech Republic in 2005 to that in 2006?
Make the answer very short. 0.81. What is the ratio of the Cost(current US$) in Sweden in 2005 to that in 2006?
Ensure brevity in your answer.  0.99. What is the difference between the highest and the second highest Cost(current US$) of Bulgaria?
Give a very brief answer. 1.33e+08. What is the difference between the highest and the second highest Cost(current US$) in Czech Republic?
Offer a terse response. 1.19e+09. What is the difference between the highest and the second highest Cost(current US$) of Sweden?
Provide a succinct answer. 1.61e+08. What is the difference between the highest and the lowest Cost(current US$) of Bulgaria?
Your answer should be very brief. 8.57e+08. What is the difference between the highest and the lowest Cost(current US$) in Czech Republic?
Keep it short and to the point. 3.95e+09. What is the difference between the highest and the lowest Cost(current US$) in Sweden?
Your response must be concise. 1.03e+1. 